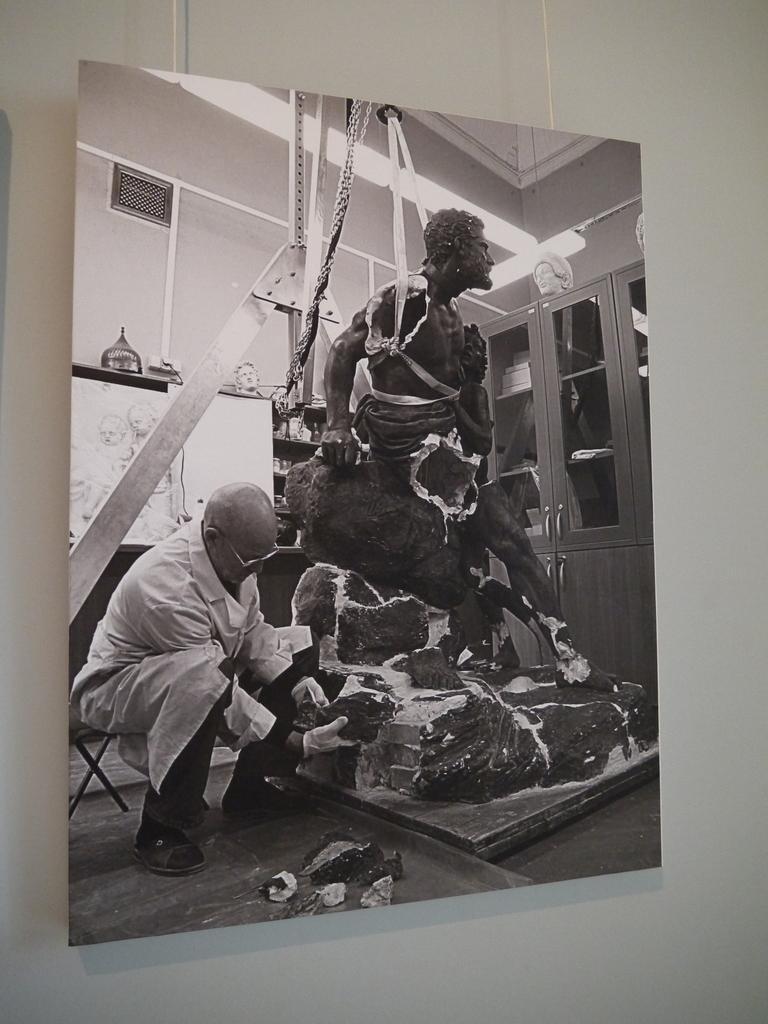Describe this image in one or two sentences. In this image I can see the white colored wall to which I can see a photograph is hanged. In the photograph I can see a person wearing white and black colored dress is sitting on a chair and holding a rock. I can see a statue which is black in color, a wall, few cabinets, few lights and few other objects. 